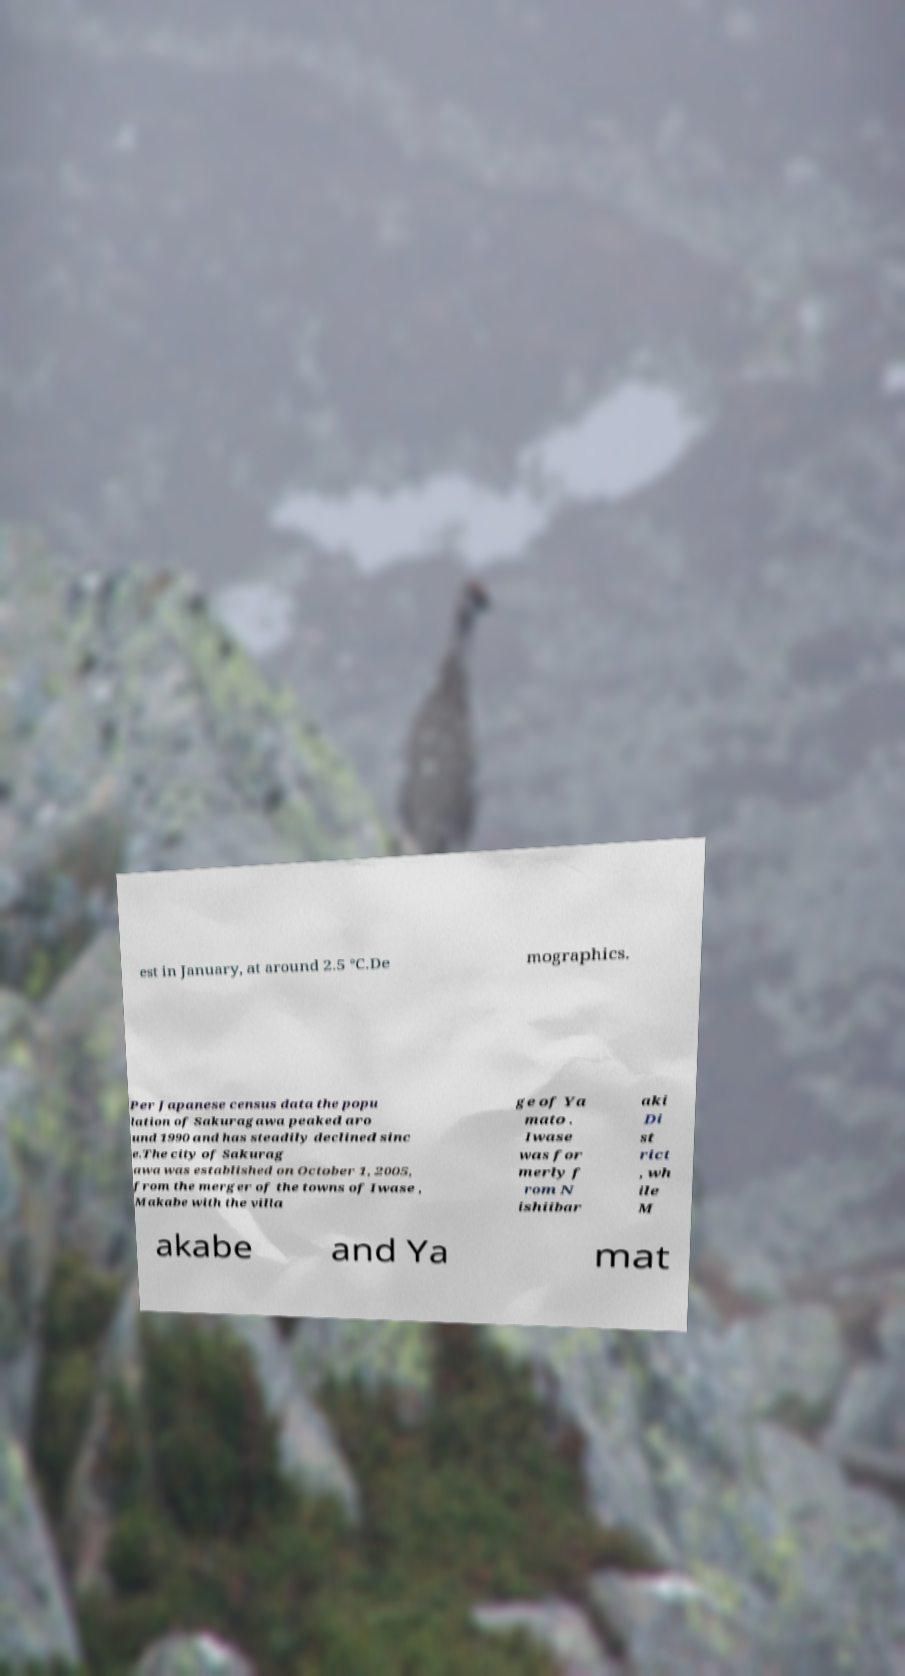There's text embedded in this image that I need extracted. Can you transcribe it verbatim? est in January, at around 2.5 °C.De mographics. Per Japanese census data the popu lation of Sakuragawa peaked aro und 1990 and has steadily declined sinc e.The city of Sakurag awa was established on October 1, 2005, from the merger of the towns of Iwase , Makabe with the villa ge of Ya mato . Iwase was for merly f rom N ishiibar aki Di st rict , wh ile M akabe and Ya mat 